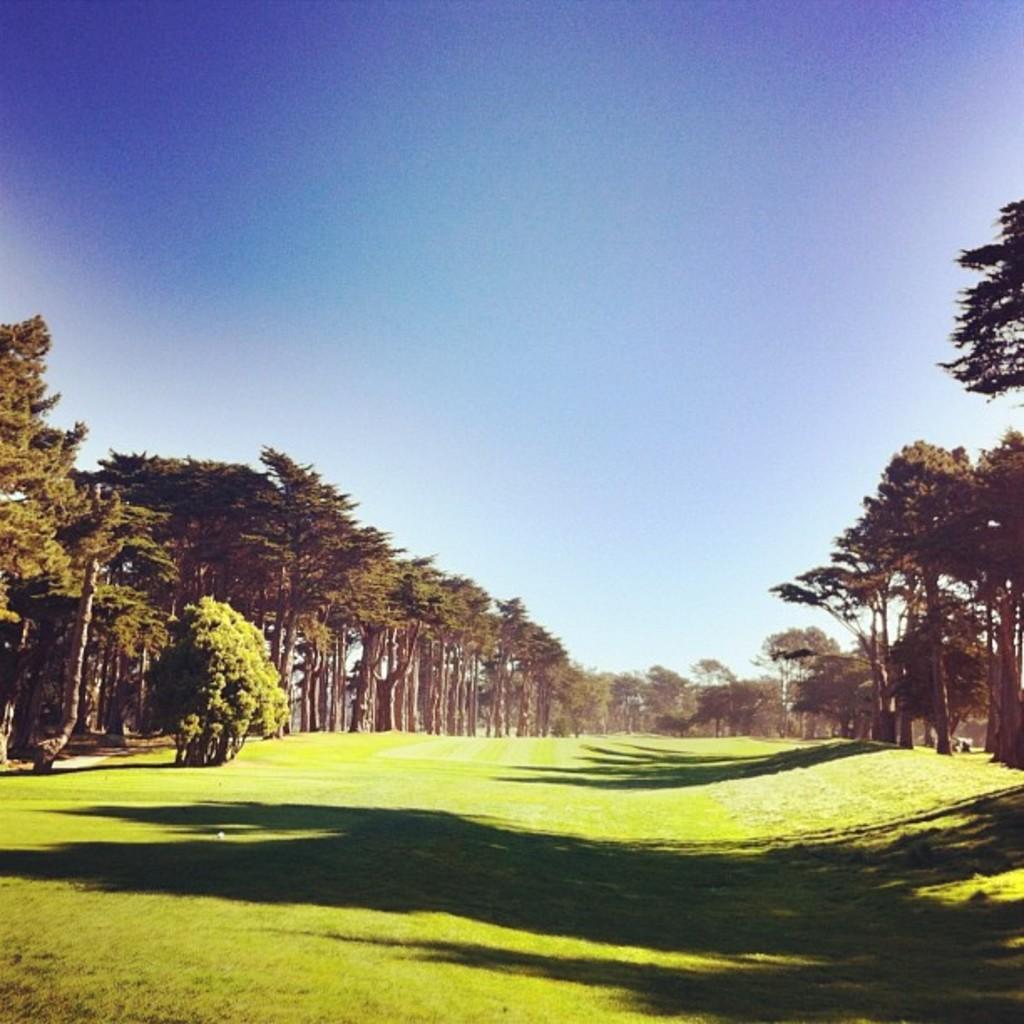Describe this image in one or two sentences. In the image there is a garden and around the garden there are many trees. 